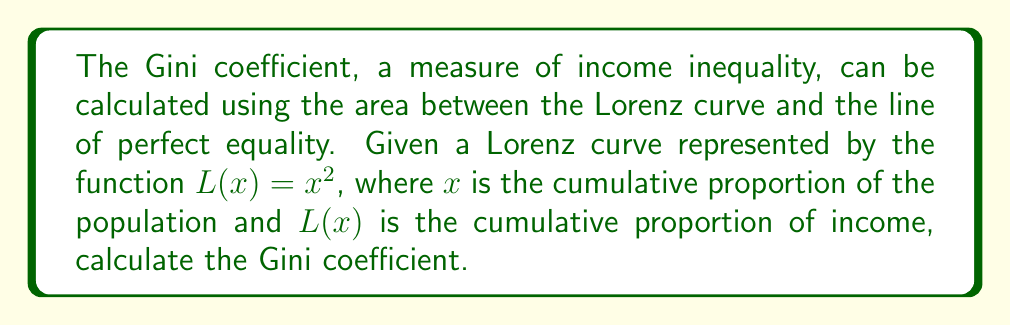Solve this math problem. To solve this problem, we'll follow these steps:

1) The Gini coefficient is defined as the area between the line of perfect equality (y = x) and the Lorenz curve, divided by the total area under the line of perfect equality.

2) The area between the curves is given by the integral of the difference between y = x and L(x) = x^2:

   $$A = \int_0^1 (x - x^2) dx$$

3) Let's solve this integral:

   $$A = \int_0^1 (x - x^2) dx = [\frac{x^2}{2} - \frac{x^3}{3}]_0^1$$

4) Evaluate the integral:

   $$A = (\frac{1}{2} - \frac{1}{3}) - (0 - 0) = \frac{1}{2} - \frac{1}{3} = \frac{1}{6}$$

5) The total area under the line of perfect equality (y = x) from 0 to 1 is 1/2.

6) The Gini coefficient is the area we calculated divided by 1/2:

   $$Gini = \frac{A}{1/2} = \frac{1/6}{1/2} = \frac{1}{3}$$

Therefore, the Gini coefficient for this Lorenz curve is 1/3.
Answer: $\frac{1}{3}$ 